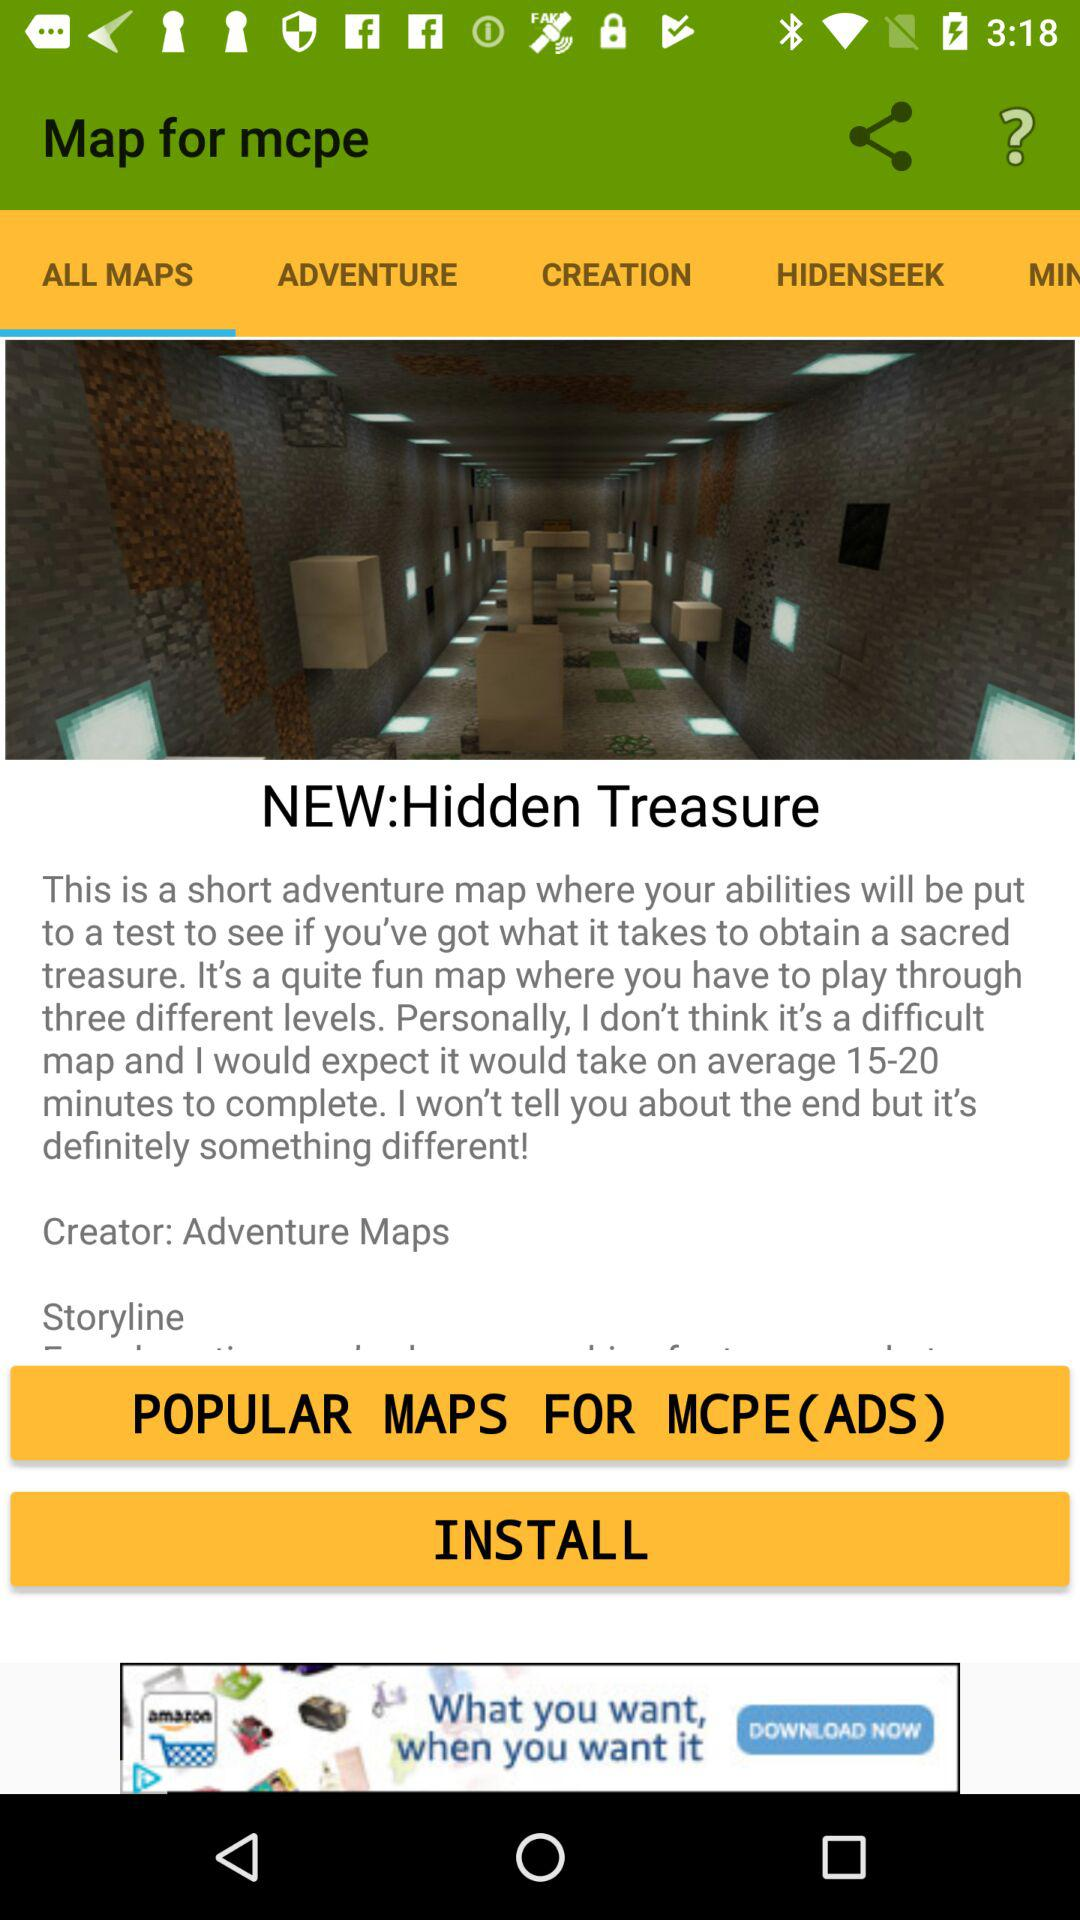Which tab is selected? The selected tab is "ALL MAPS". 